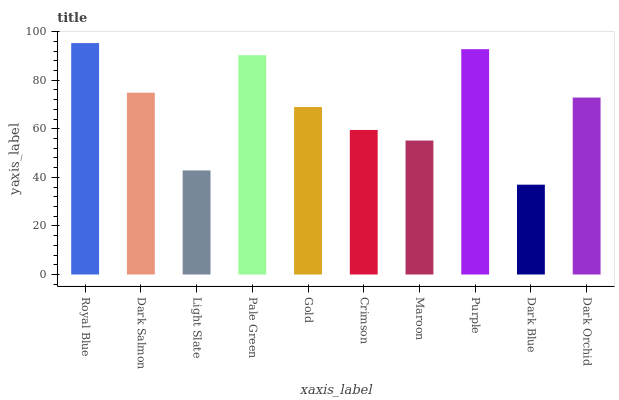Is Dark Blue the minimum?
Answer yes or no. Yes. Is Royal Blue the maximum?
Answer yes or no. Yes. Is Dark Salmon the minimum?
Answer yes or no. No. Is Dark Salmon the maximum?
Answer yes or no. No. Is Royal Blue greater than Dark Salmon?
Answer yes or no. Yes. Is Dark Salmon less than Royal Blue?
Answer yes or no. Yes. Is Dark Salmon greater than Royal Blue?
Answer yes or no. No. Is Royal Blue less than Dark Salmon?
Answer yes or no. No. Is Dark Orchid the high median?
Answer yes or no. Yes. Is Gold the low median?
Answer yes or no. Yes. Is Maroon the high median?
Answer yes or no. No. Is Dark Blue the low median?
Answer yes or no. No. 